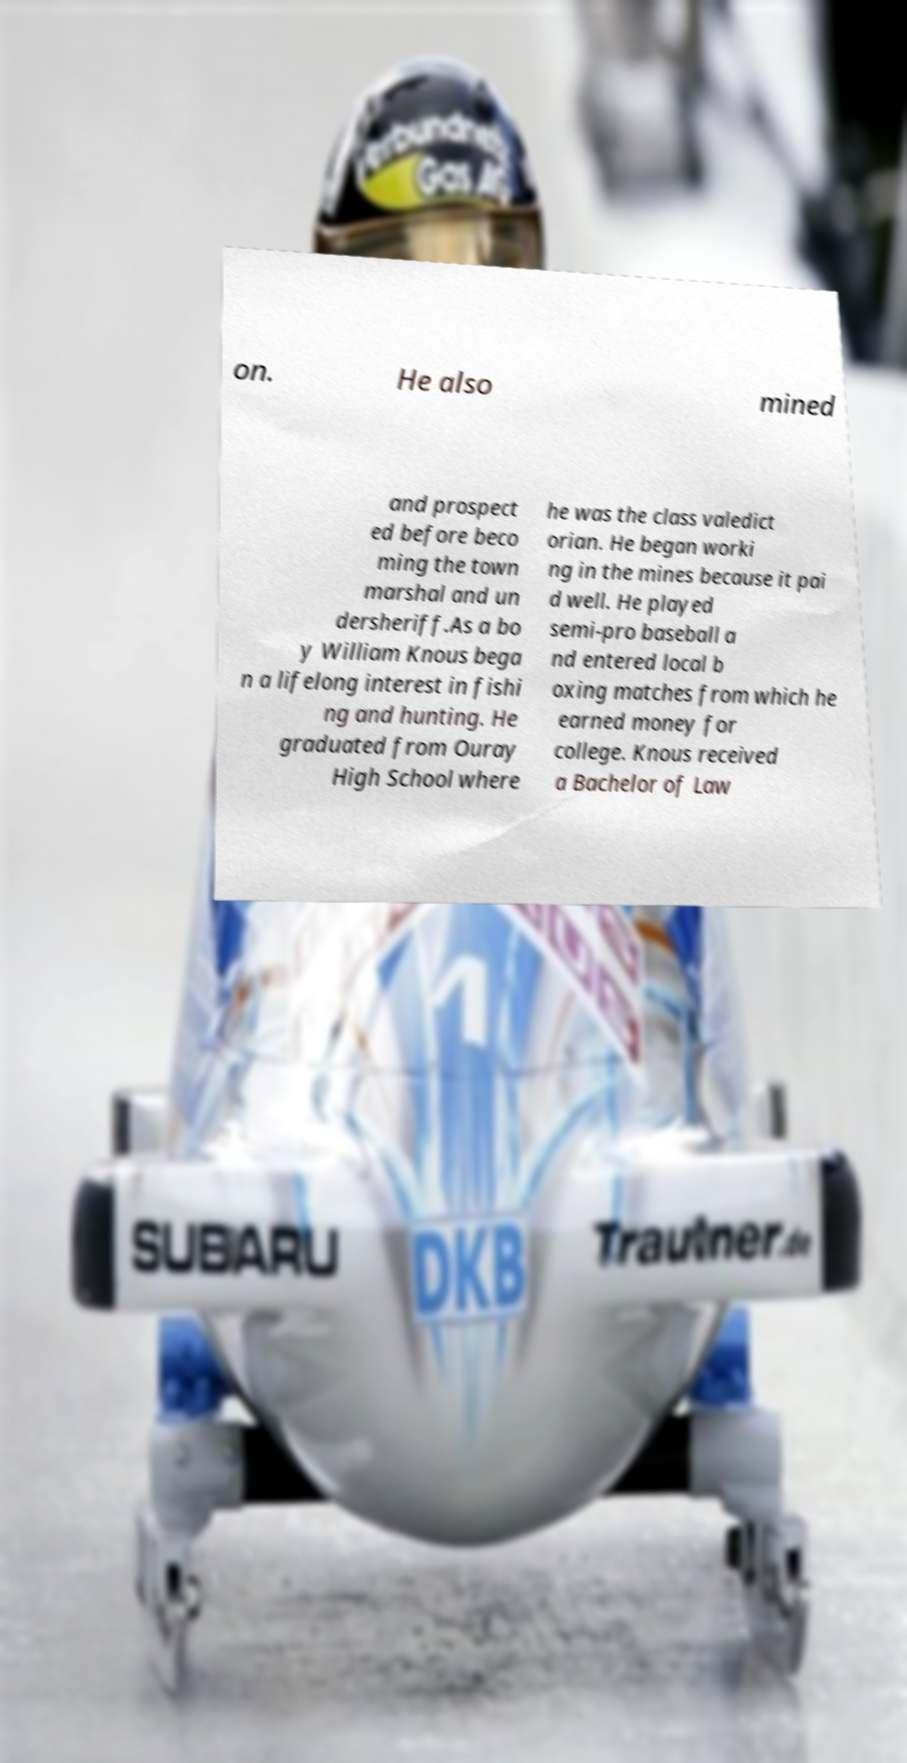Could you assist in decoding the text presented in this image and type it out clearly? on. He also mined and prospect ed before beco ming the town marshal and un dersheriff.As a bo y William Knous bega n a lifelong interest in fishi ng and hunting. He graduated from Ouray High School where he was the class valedict orian. He began worki ng in the mines because it pai d well. He played semi-pro baseball a nd entered local b oxing matches from which he earned money for college. Knous received a Bachelor of Law 